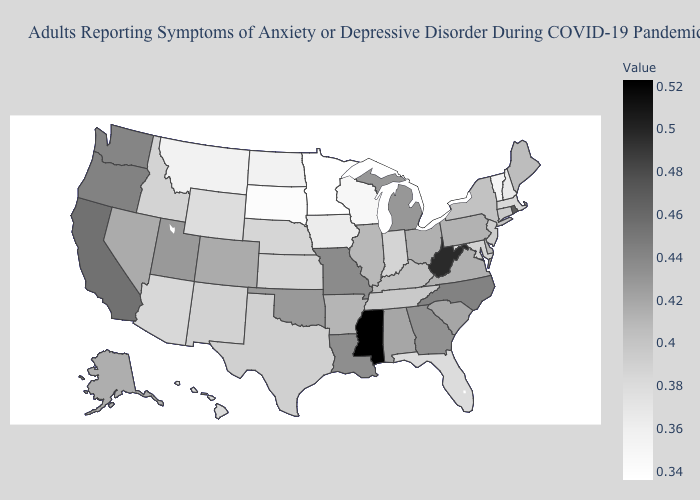Among the states that border Maryland , does West Virginia have the highest value?
Be succinct. Yes. Which states have the highest value in the USA?
Concise answer only. Mississippi. Does Mississippi have the highest value in the USA?
Answer briefly. Yes. Is the legend a continuous bar?
Quick response, please. Yes. Among the states that border Maryland , which have the highest value?
Concise answer only. West Virginia. Does Minnesota have the lowest value in the USA?
Be succinct. Yes. Does the map have missing data?
Give a very brief answer. No. 